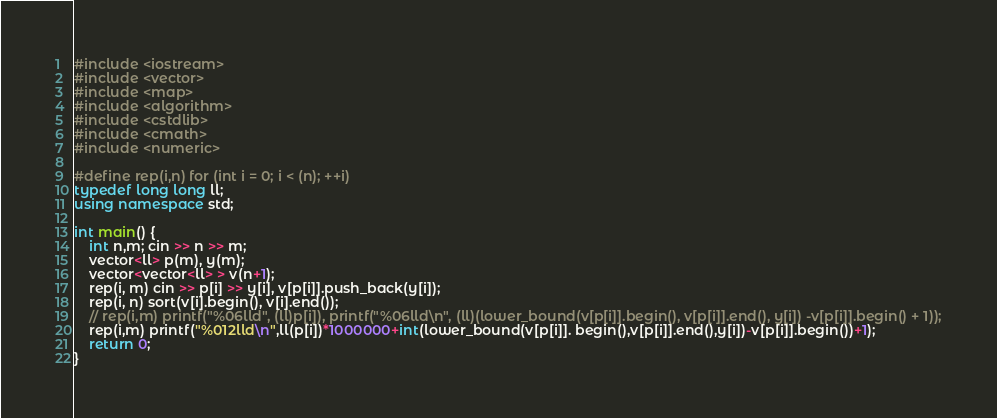<code> <loc_0><loc_0><loc_500><loc_500><_C++_>#include <iostream>
#include <vector>
#include <map>
#include <algorithm>
#include <cstdlib>
#include <cmath>
#include <numeric>

#define rep(i,n) for (int i = 0; i < (n); ++i)
typedef long long ll;
using namespace std;

int main() {
    int n,m; cin >> n >> m;
    vector<ll> p(m), y(m);
    vector<vector<ll> > v(n+1);
    rep(i, m) cin >> p[i] >> y[i], v[p[i]].push_back(y[i]);
    rep(i, n) sort(v[i].begin(), v[i].end());
    // rep(i,m) printf("%06lld", (ll)p[i]), printf("%06lld\n", (ll)(lower_bound(v[p[i]].begin(), v[p[i]].end(), y[i]) -v[p[i]].begin() + 1));
    rep(i,m) printf("%012lld\n",ll(p[i])*1000000+int(lower_bound(v[p[i]]. begin(),v[p[i]].end(),y[i])-v[p[i]].begin())+1);
    return 0;
}</code> 